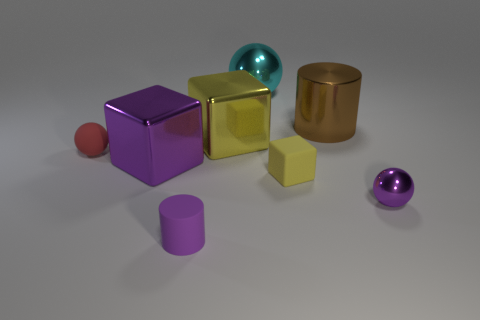There is a metallic cube left of the small purple rubber thing; what is its color? The cube to the left of the small purple rubber object has a gold color, with a shiny metallic texture that distinguishes it from the other matte objects in the scene. 